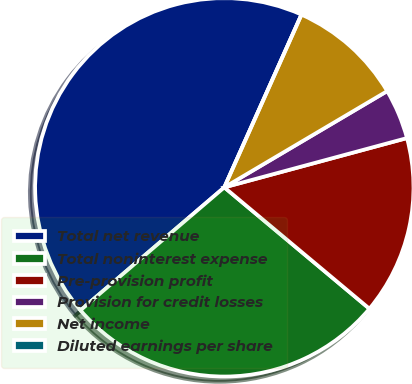Convert chart. <chart><loc_0><loc_0><loc_500><loc_500><pie_chart><fcel>Total net revenue<fcel>Total noninterest expense<fcel>Pre-provision profit<fcel>Provision for credit losses<fcel>Net income<fcel>Diluted earnings per share<nl><fcel>42.94%<fcel>27.66%<fcel>15.28%<fcel>4.3%<fcel>9.82%<fcel>0.0%<nl></chart> 